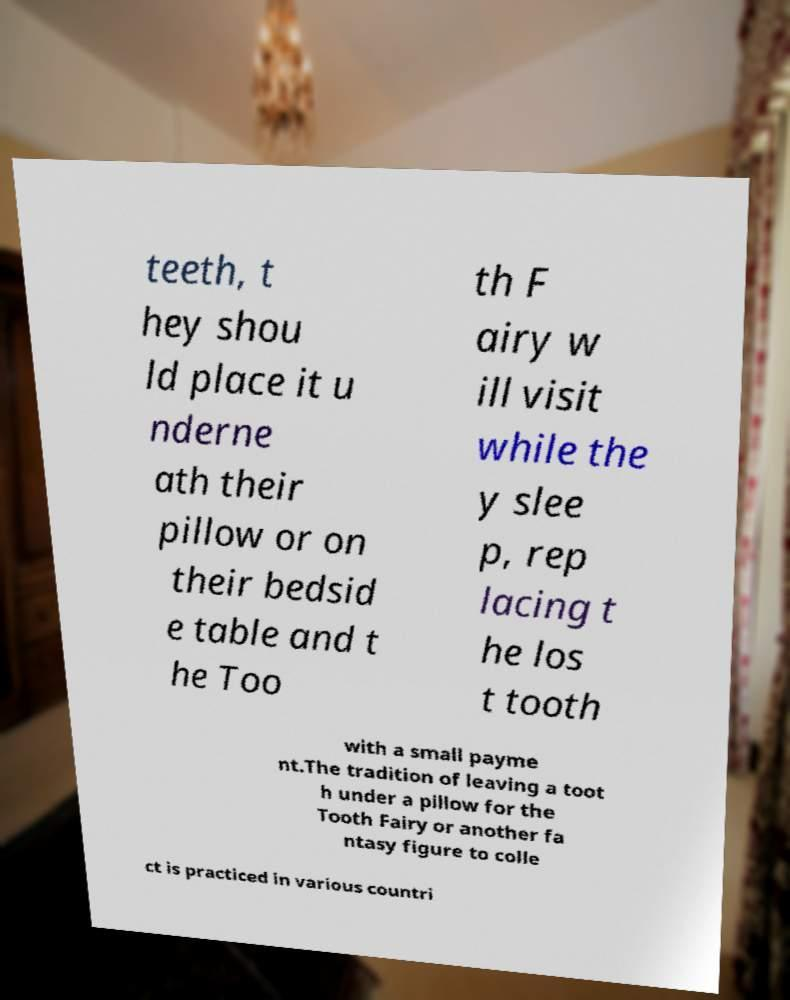Please read and relay the text visible in this image. What does it say? teeth, t hey shou ld place it u nderne ath their pillow or on their bedsid e table and t he Too th F airy w ill visit while the y slee p, rep lacing t he los t tooth with a small payme nt.The tradition of leaving a toot h under a pillow for the Tooth Fairy or another fa ntasy figure to colle ct is practiced in various countri 